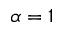<formula> <loc_0><loc_0><loc_500><loc_500>\alpha = 1</formula> 